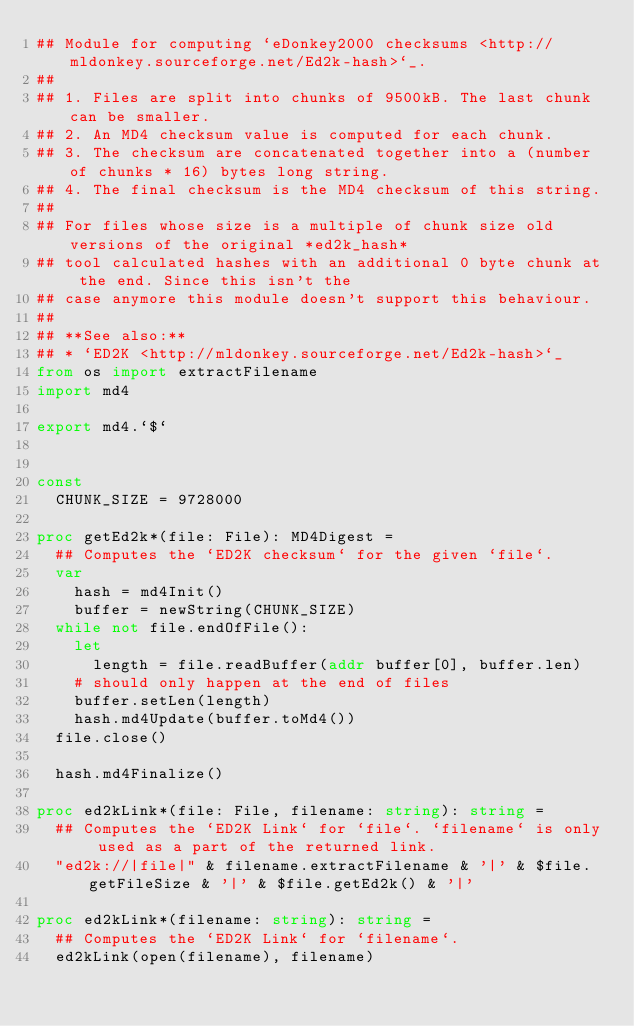<code> <loc_0><loc_0><loc_500><loc_500><_Nim_>## Module for computing `eDonkey2000 checksums <http://mldonkey.sourceforge.net/Ed2k-hash>`_.
##
## 1. Files are split into chunks of 9500kB. The last chunk can be smaller.
## 2. An MD4 checksum value is computed for each chunk.
## 3. The checksum are concatenated together into a (number of chunks * 16) bytes long string.
## 4. The final checksum is the MD4 checksum of this string.
##
## For files whose size is a multiple of chunk size old versions of the original *ed2k_hash*
## tool calculated hashes with an additional 0 byte chunk at the end. Since this isn't the
## case anymore this module doesn't support this behaviour.
##
## **See also:**
## * `ED2K <http://mldonkey.sourceforge.net/Ed2k-hash>`_
from os import extractFilename
import md4

export md4.`$`


const
  CHUNK_SIZE = 9728000

proc getEd2k*(file: File): MD4Digest =
  ## Computes the `ED2K checksum` for the given `file`.
  var
    hash = md4Init()
    buffer = newString(CHUNK_SIZE)
  while not file.endOfFile():
    let
      length = file.readBuffer(addr buffer[0], buffer.len)
    # should only happen at the end of files
    buffer.setLen(length)
    hash.md4Update(buffer.toMd4())
  file.close()

  hash.md4Finalize()

proc ed2kLink*(file: File, filename: string): string =
  ## Computes the `ED2K Link` for `file`. `filename` is only used as a part of the returned link.
  "ed2k://|file|" & filename.extractFilename & '|' & $file.getFileSize & '|' & $file.getEd2k() & '|'

proc ed2kLink*(filename: string): string =
  ## Computes the `ED2K Link` for `filename`.
  ed2kLink(open(filename), filename)
</code> 